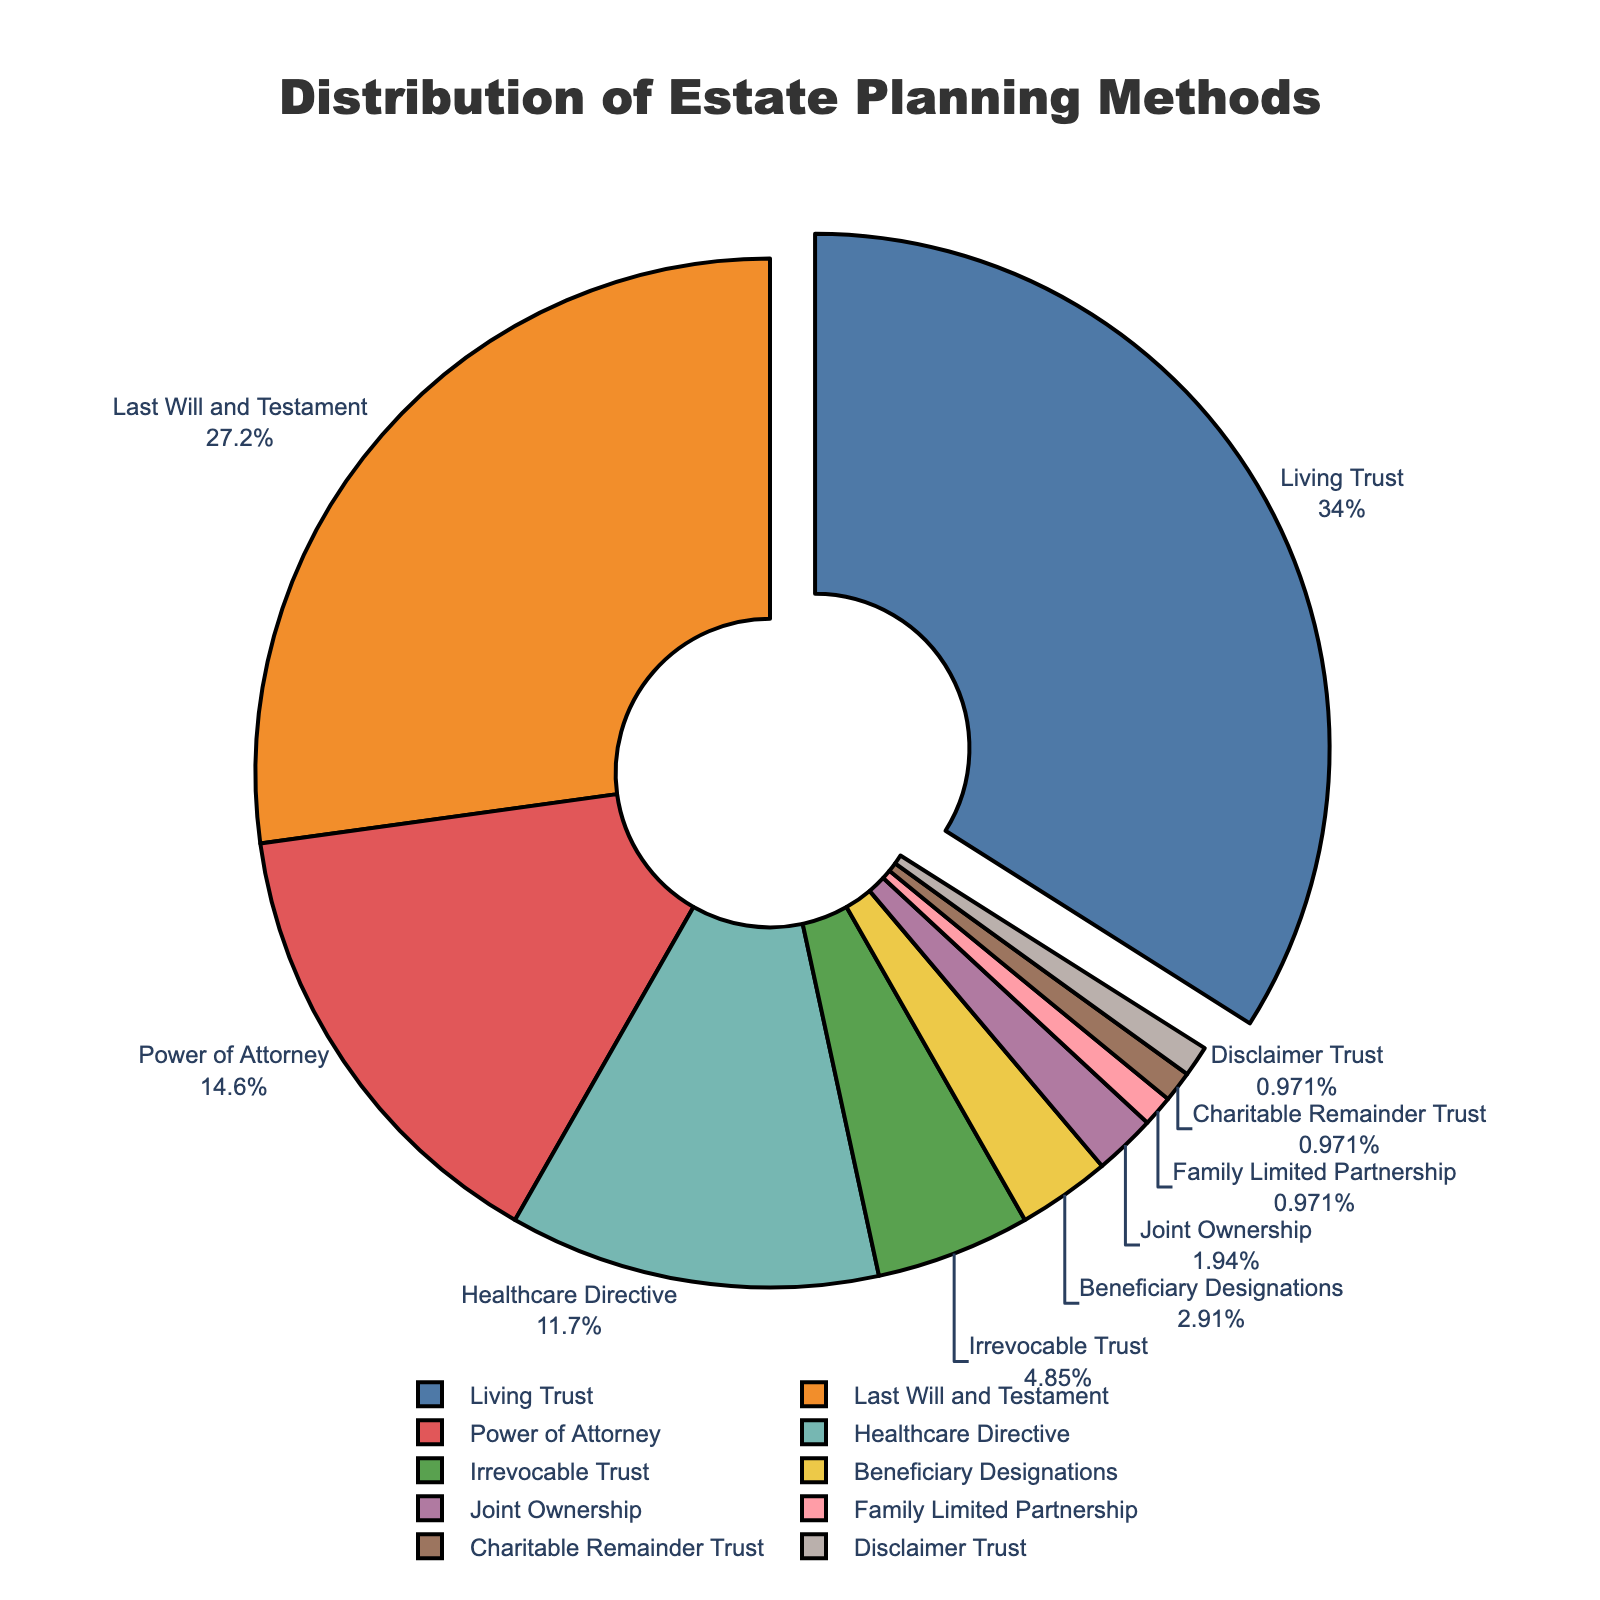What's the estate planning method used by the highest percentage of clients? The figure shows that the largest portion of the pie chart, which is pulled out slightly, represents the "Living Trust" and is 35%.
Answer: Living Trust Which three estate planning methods are used by more than 10% of clients? By observing the pie chart, the segments with percentages greater than 10% are "Living Trust" (35%), "Last Will and Testament" (28%), and "Power of Attorney" (15%).
Answer: Living Trust, Last Will and Testament, Power of Attorney What is the combined percentage of clients using either "Living Trust" or "Last Will and Testament"? Add the percentages for "Living Trust" and "Last Will and Testament": 35% + 28% = 63%.
Answer: 63% Which estate planning methods are used by the same (smallest) percentage of clients? The smallest percentages on the pie chart, which are equal at 1%, are "Family Limited Partnership", "Charitable Remainder Trust", and "Disclaimer Trust".
Answer: Family Limited Partnership, Charitable Remainder Trust, Disclaimer Trust What is the difference in percentage between clients using "Healthcare Directive" and those using "Power of Attorney"? Subtract the percentage of "Healthcare Directive" from "Power of Attorney": 15% - 12% = 3%.
Answer: 3% How does the percentage of clients using "Beneficiary Designations" compare to those using "Joint Ownership"? The percentage for "Beneficiary Designations" (3%) is slightly higher than that for "Joint Ownership" (2%).
Answer: Beneficiary Designations is higher What is the visual cue used to emphasize the estate planning method used by the highest percentage of clients? The largest segment representing "Living Trust" is slightly pulled out from the pie chart to emphasize it.
Answer: Pulled out segment What percentage of clients use either "Irrevocable Trust" or "Healthcare Directive"? Add the percentages for "Irrevocable Trust" and "Healthcare Directive": 5% + 12% = 17%.
Answer: 17% What is the difference between the sum of the smallest three percentages and the percentage of clients using "Power of Attorney"? The three smallest percentages are "Family Limited Partnership" (1%), "Charitable Remainder Trust" (1%), and "Disclaimer Trust" (1%). Their sum is 3%. The percentage for "Power of Attorney" is 15%. The difference is 15% - 3% = 12%.
Answer: 12% Which estate planning method used by clients has a percentage exactly five times greater than "Joint Ownership"? "Joint Ownership" is used by 2% of clients. The method with a percentage five times greater than 2% is "Power of Attorney" at 10%. However, "Power of Attorney" is actually 15%. So, there is no exact match with five times greater.
Answer: None 